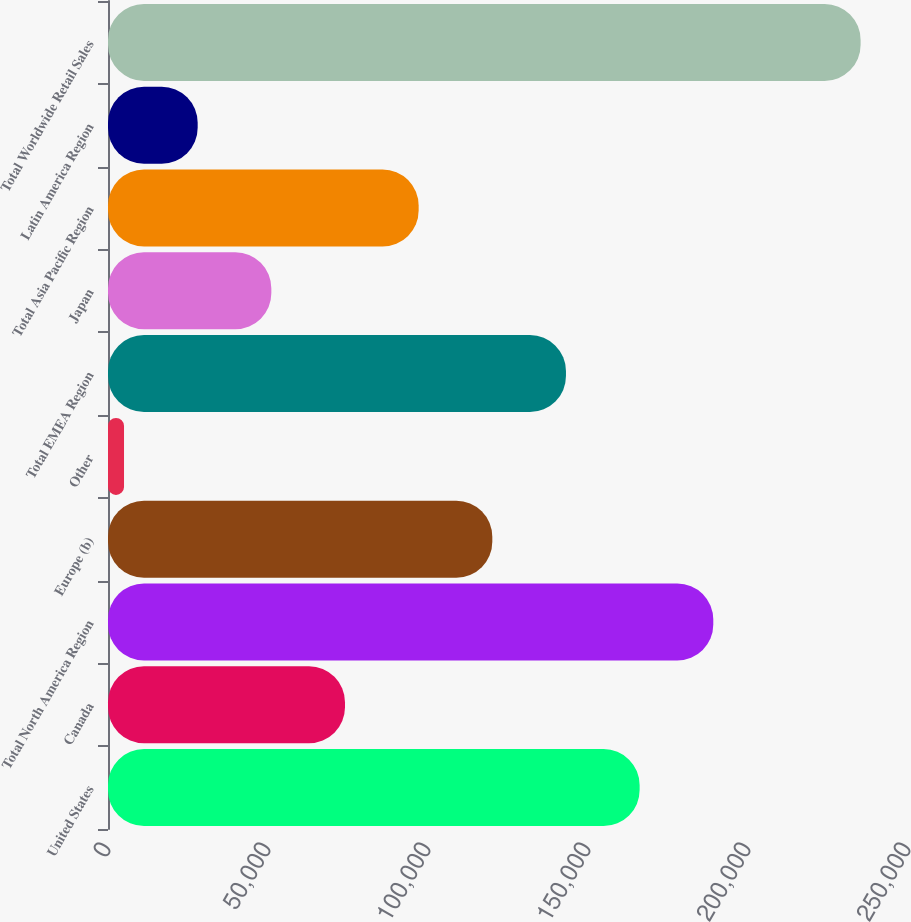<chart> <loc_0><loc_0><loc_500><loc_500><bar_chart><fcel>United States<fcel>Canada<fcel>Total North America Region<fcel>Europe (b)<fcel>Other<fcel>Total EMEA Region<fcel>Japan<fcel>Total Asia Pacific Region<fcel>Latin America Region<fcel>Total Worldwide Retail Sales<nl><fcel>166133<fcel>74060.6<fcel>189152<fcel>120097<fcel>5006<fcel>143115<fcel>51042.4<fcel>97078.8<fcel>28024.2<fcel>235188<nl></chart> 